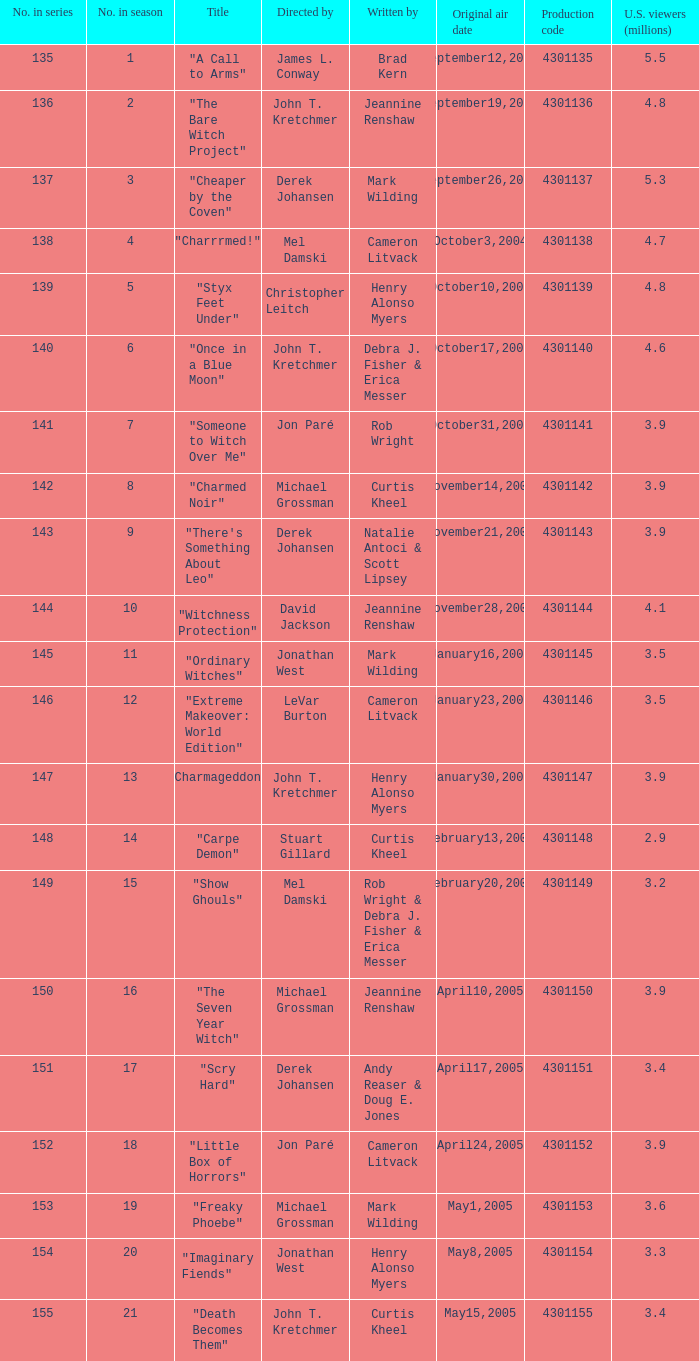What was the appellation of the episode that drew "Imaginary Fiends". 